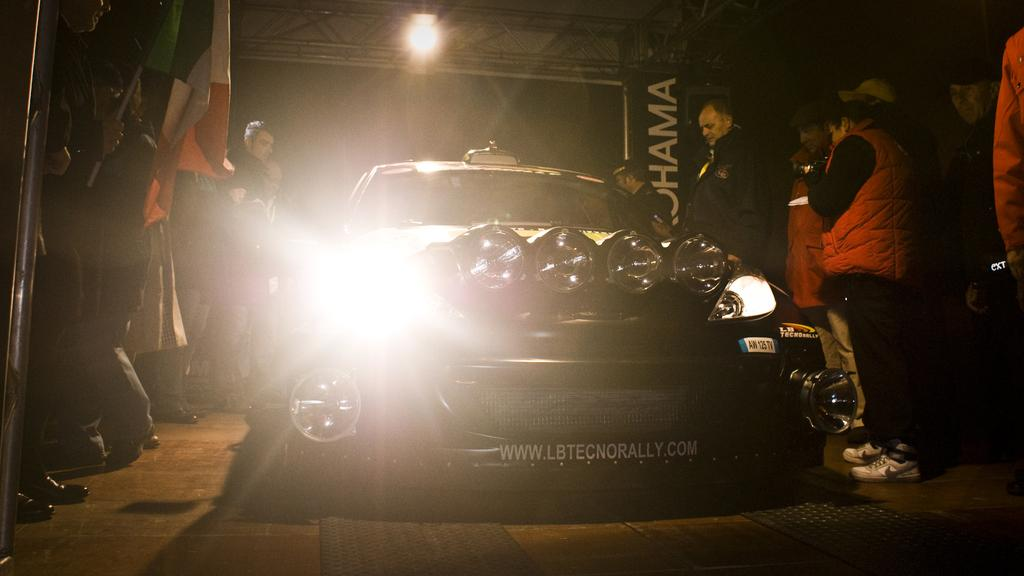What is the main subject of the image? There is a car on the road in the image. Are there any people in the image? Yes, there are people standing beside the car. What can be seen in the background of the image? The background of the image is dark. What else is present in the image besides the car and people? There are flags, a banner, and lights visible in the image. How many ants can be seen crawling on the car in the image? There are no ants visible in the image; it only features a car, people, flags, a banner, lights, and a dark background. What type of bomb is being defused in the image? There is no bomb present in the image; it only features a car, people, flags, a banner, lights, and a dark background. 